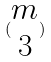<formula> <loc_0><loc_0><loc_500><loc_500>( \begin{matrix} m \\ 3 \end{matrix} )</formula> 